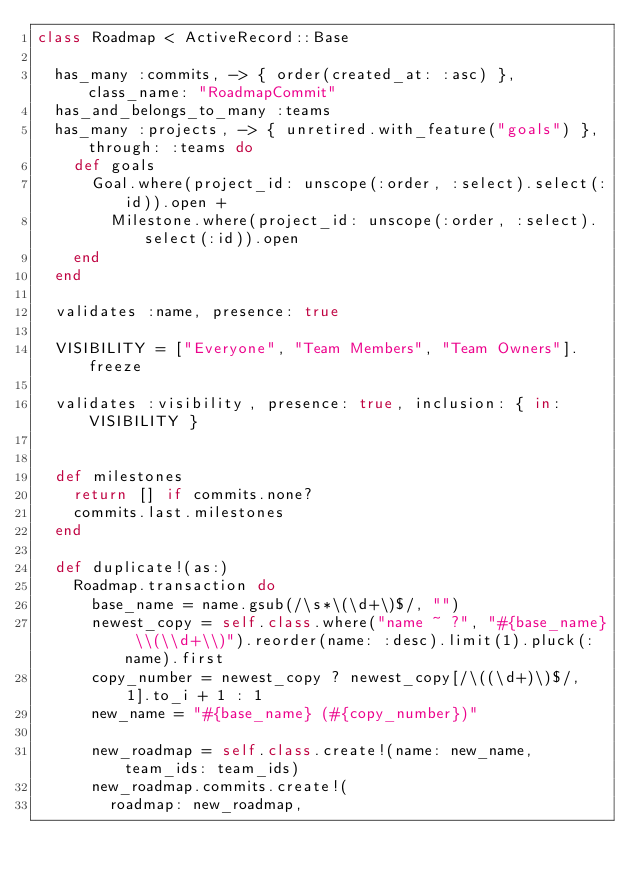Convert code to text. <code><loc_0><loc_0><loc_500><loc_500><_Ruby_>class Roadmap < ActiveRecord::Base

  has_many :commits, -> { order(created_at: :asc) }, class_name: "RoadmapCommit"
  has_and_belongs_to_many :teams
  has_many :projects, -> { unretired.with_feature("goals") }, through: :teams do
    def goals
      Goal.where(project_id: unscope(:order, :select).select(:id)).open +
        Milestone.where(project_id: unscope(:order, :select).select(:id)).open
    end
  end

  validates :name, presence: true

  VISIBILITY = ["Everyone", "Team Members", "Team Owners"].freeze

  validates :visibility, presence: true, inclusion: { in: VISIBILITY }


  def milestones
    return [] if commits.none?
    commits.last.milestones
  end

  def duplicate!(as:)
    Roadmap.transaction do
      base_name = name.gsub(/\s*\(\d+\)$/, "")
      newest_copy = self.class.where("name ~ ?", "#{base_name} \\(\\d+\\)").reorder(name: :desc).limit(1).pluck(:name).first
      copy_number = newest_copy ? newest_copy[/\((\d+)\)$/, 1].to_i + 1 : 1
      new_name = "#{base_name} (#{copy_number})"

      new_roadmap = self.class.create!(name: new_name, team_ids: team_ids)
      new_roadmap.commits.create!(
        roadmap: new_roadmap,</code> 